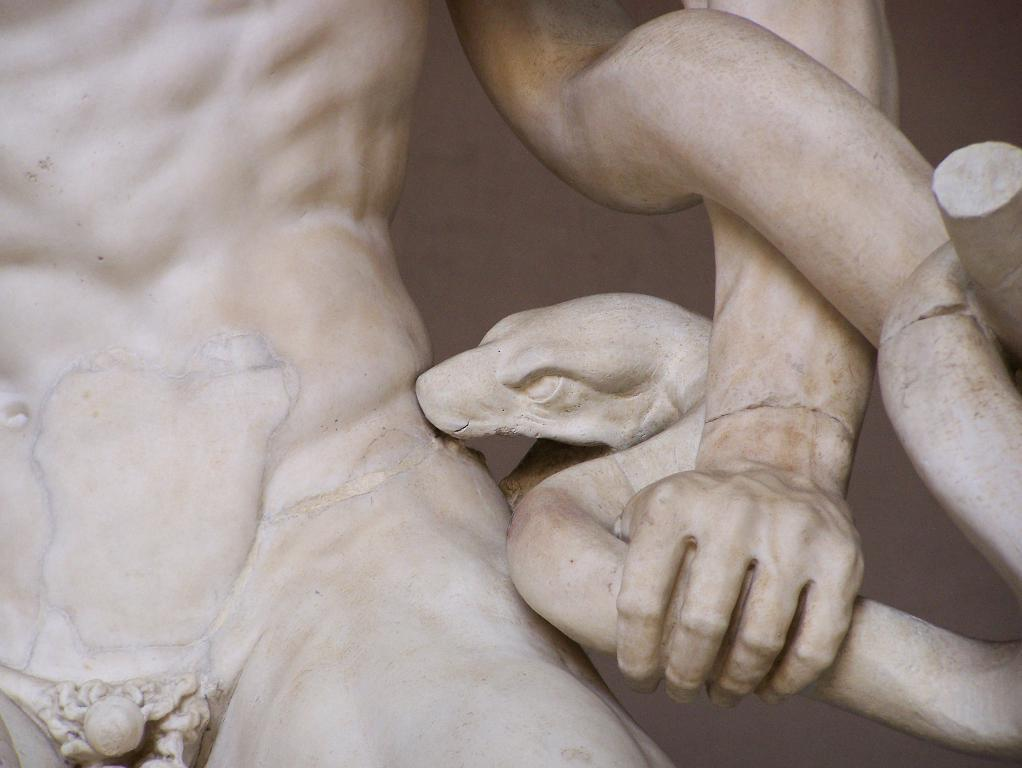What is the main subject of the image? There is a statue in the image. What type of pen is the statue holding in the image? There is no pen present in the image, as it only features a statue. 